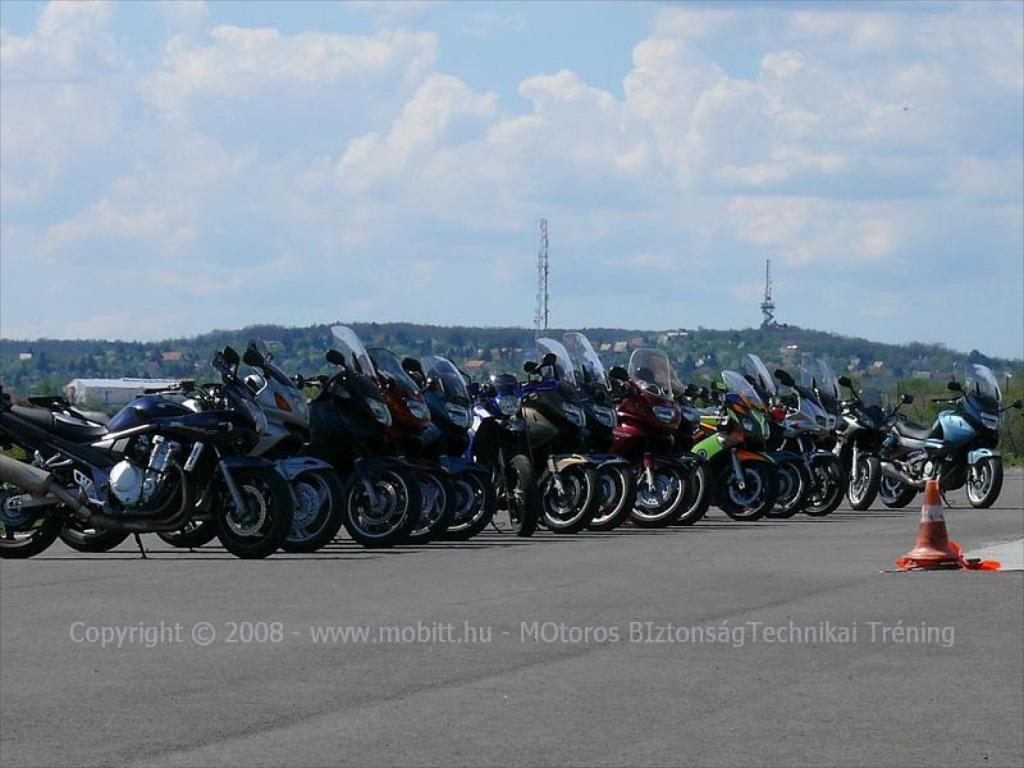In one or two sentences, can you explain what this image depicts? In this image, we can see motorbikes are parked on the road. Right side of the image, we can see a traffic cone. Background there are so many trees, plants, sheds, towers we can see. top ,of the image, there is a cloudy sky. 